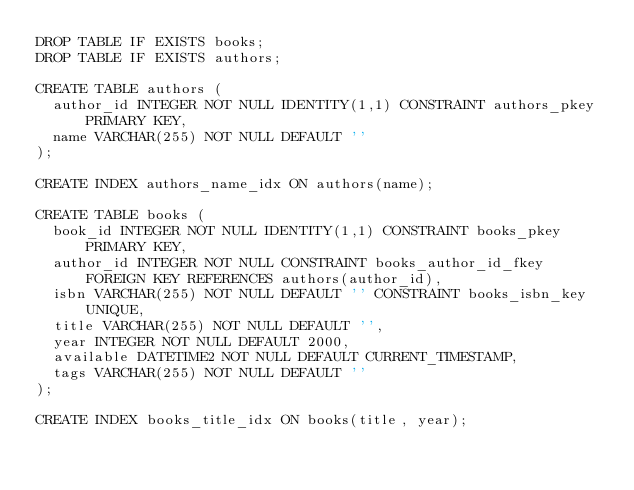<code> <loc_0><loc_0><loc_500><loc_500><_SQL_>DROP TABLE IF EXISTS books;
DROP TABLE IF EXISTS authors;

CREATE TABLE authors (
  author_id INTEGER NOT NULL IDENTITY(1,1) CONSTRAINT authors_pkey PRIMARY KEY,
  name VARCHAR(255) NOT NULL DEFAULT ''
);

CREATE INDEX authors_name_idx ON authors(name);

CREATE TABLE books (
  book_id INTEGER NOT NULL IDENTITY(1,1) CONSTRAINT books_pkey PRIMARY KEY,
  author_id INTEGER NOT NULL CONSTRAINT books_author_id_fkey FOREIGN KEY REFERENCES authors(author_id),
  isbn VARCHAR(255) NOT NULL DEFAULT '' CONSTRAINT books_isbn_key UNIQUE,
  title VARCHAR(255) NOT NULL DEFAULT '',
  year INTEGER NOT NULL DEFAULT 2000,
  available DATETIME2 NOT NULL DEFAULT CURRENT_TIMESTAMP,
  tags VARCHAR(255) NOT NULL DEFAULT ''
);

CREATE INDEX books_title_idx ON books(title, year);
</code> 